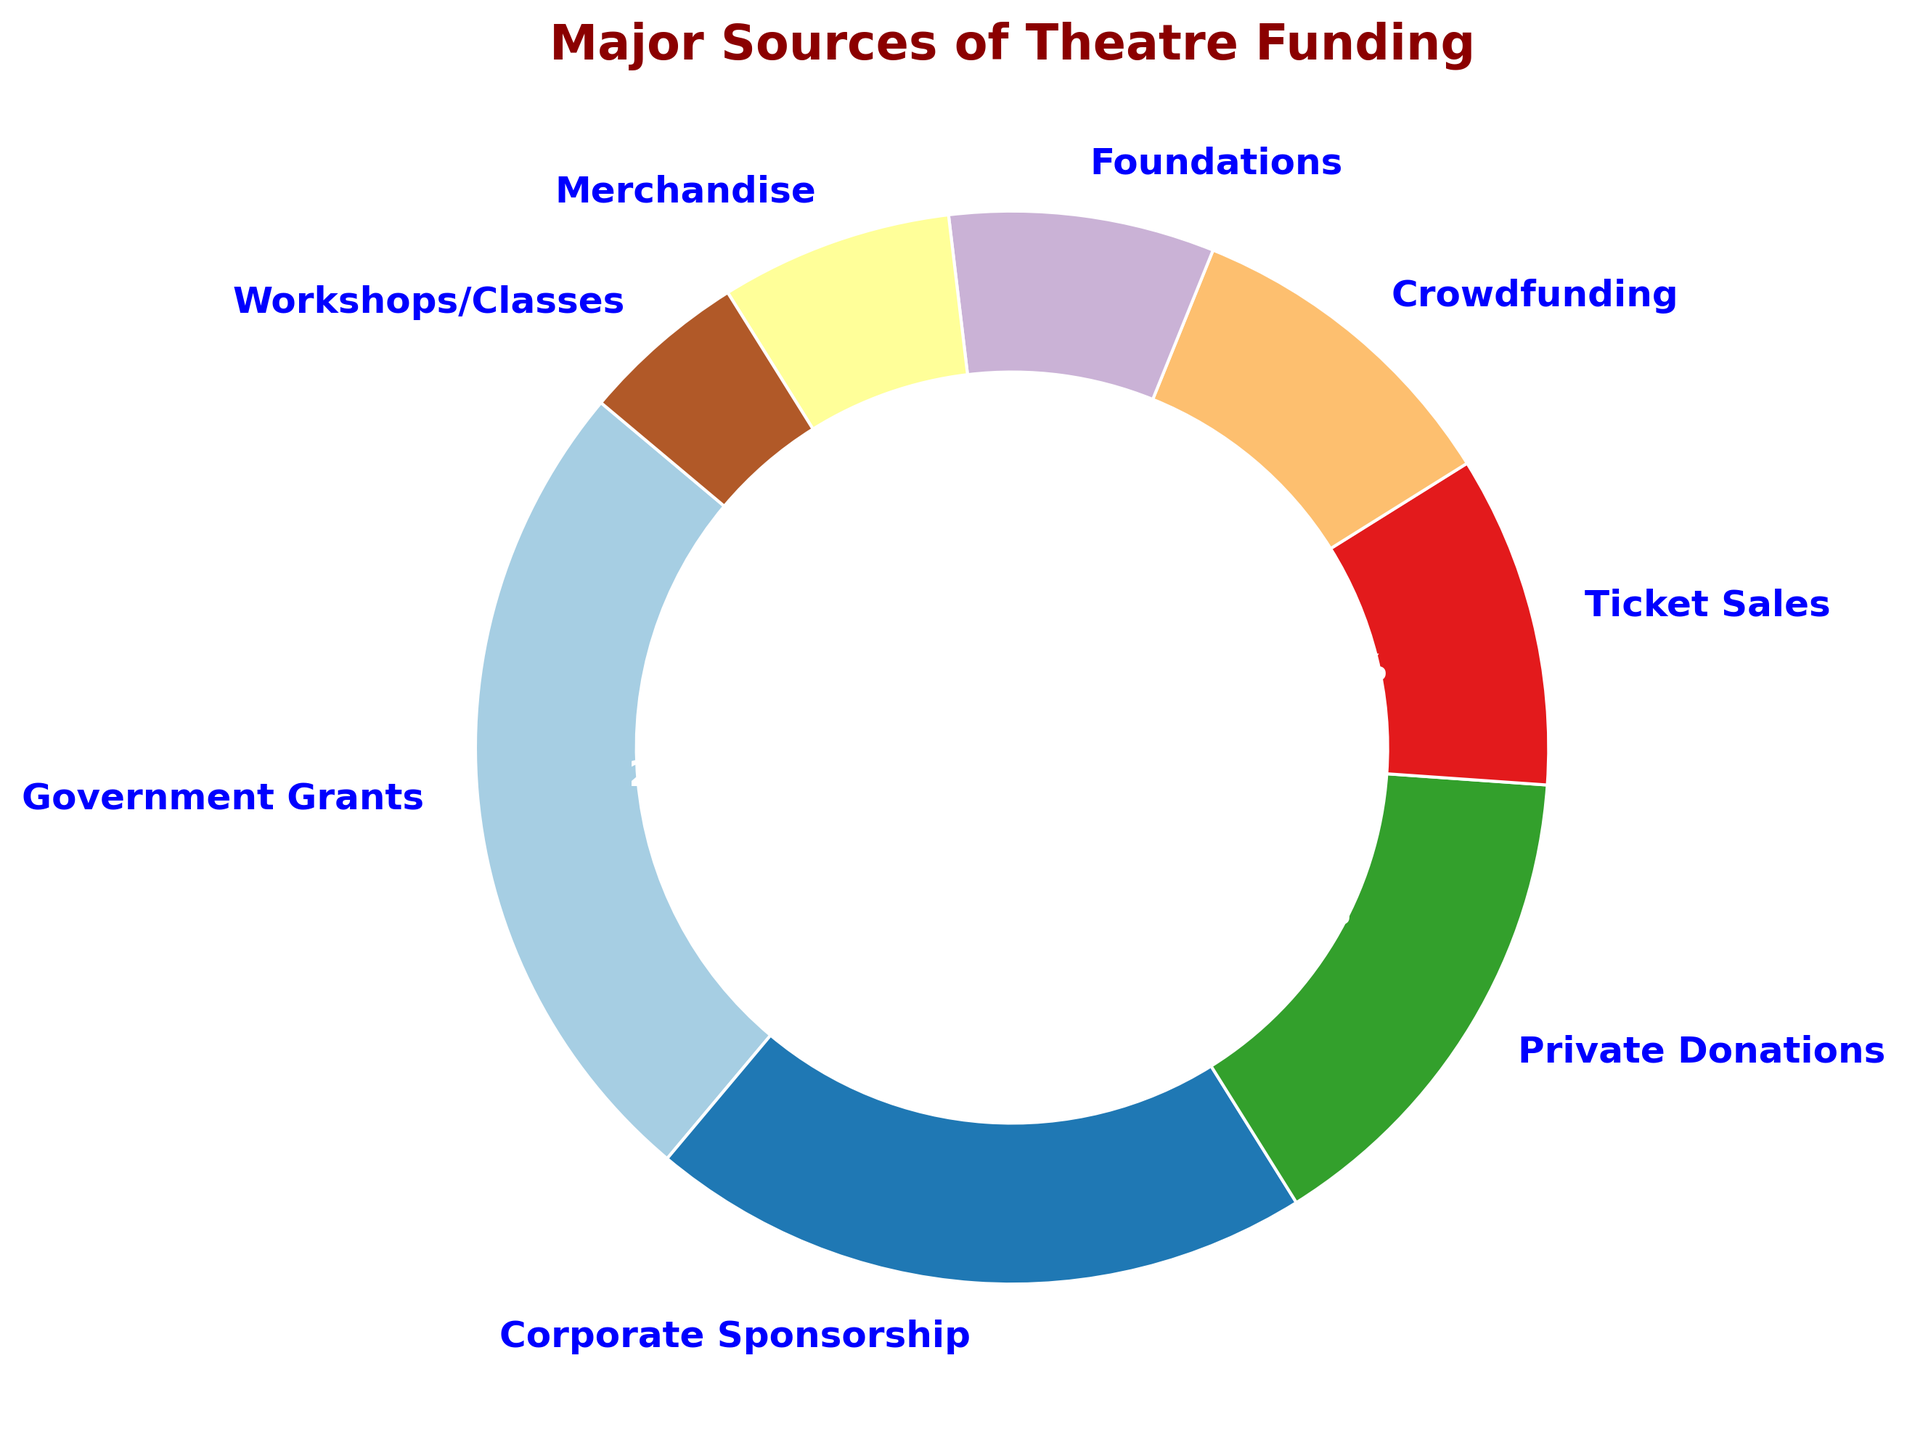What is the largest source of theatre funding? The largest source is the sector with the highest percentage section in the ring chart. In this case, it is "Government Grants" at 25%.
Answer: Government Grants Which funding type has the smallest contribution? The smallest contribution is represented by the sector with the smallest percentage. Here, it is "Workshops/Classes" at 5%.
Answer: Workshops/Classes What is the combined percentage of Ticket Sales and Crowdfunding? To find the combined percentage, sum the percentages for Ticket Sales and Crowdfunding: 10% + 10% = 20%.
Answer: 20% How does Corporate Sponsorship compare to Private Donations in terms of percentage? The percentage for Corporate Sponsorship is 20%, while for Private Donations, it is 15%. Therefore, Corporate Sponsorship is greater.
Answer: Corporate Sponsorship is greater What is the difference in percentage between Government Grants and Foundations? Subtract the percentage of Foundations from Government Grants: 25% - 8% = 17%.
Answer: 17% What is the percentage contribution of non-ticket sales sources combined? Add the percentages of all sources except Ticket Sales: 25% + 20% + 15% + 10% + 8% + 7% + 5% = 90%.
Answer: 90% Which funding source has a percentage closest to the average contribution of all sources? Calculate the average: sum all percentages and divide by the number of sources: (25% + 20% + 15% + 10% + 10% + 8% + 7% + 5%) / 8 = 12.5%. The closest to the average is Private Donations at 15%.
Answer: Private Donations What color is associated with Foundations in the ring chart? Identify the segment labeled "Foundations" and describe its color. Since specific colors are used from the Paired colormap, visually inspect the color of the Foundations segment in the ring chart.
Answer: Light Blue (visually, it should represent a distinct color from the Paired colormap) Which source's percentage is double that of Workshops/Classes? The percentage for Workshops/Classes is 5%. Double this value is 10%. Both Ticket Sales and Crowdfunding have a 10% contribution.
Answer: Ticket Sales and Crowdfunding 